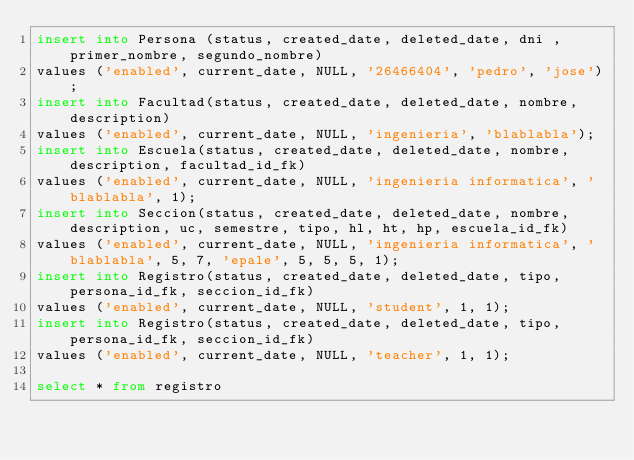<code> <loc_0><loc_0><loc_500><loc_500><_SQL_>insert into Persona (status, created_date, deleted_date, dni , primer_nombre, segundo_nombre)
values ('enabled', current_date, NULL, '26466404', 'pedro', 'jose');
insert into Facultad(status, created_date, deleted_date, nombre, description)
values ('enabled', current_date, NULL, 'ingenieria', 'blablabla');
insert into Escuela(status, created_date, deleted_date, nombre, description, facultad_id_fk)
values ('enabled', current_date, NULL, 'ingenieria informatica', 'blablabla', 1);
insert into Seccion(status, created_date, deleted_date, nombre, description, uc, semestre, tipo, hl, ht, hp, escuela_id_fk)
values ('enabled', current_date, NULL, 'ingenieria informatica', 'blablabla', 5, 7, 'epale', 5, 5, 5, 1);
insert into Registro(status, created_date, deleted_date, tipo, persona_id_fk, seccion_id_fk)
values ('enabled', current_date, NULL, 'student', 1, 1);
insert into Registro(status, created_date, deleted_date, tipo, persona_id_fk, seccion_id_fk)
values ('enabled', current_date, NULL, 'teacher', 1, 1);

select * from registro</code> 